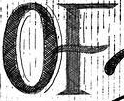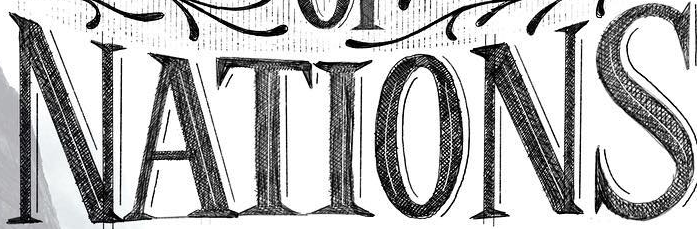Read the text from these images in sequence, separated by a semicolon. OF; NATIONS 